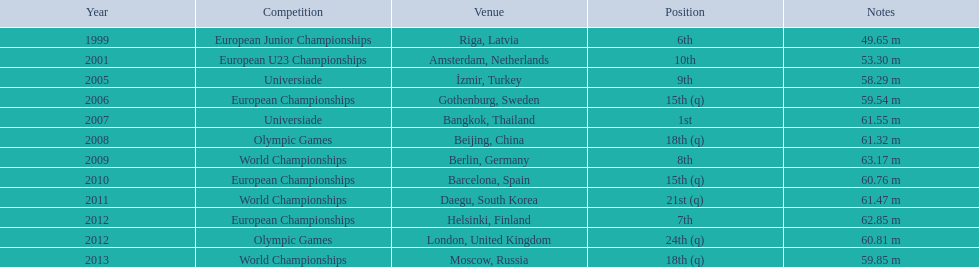Before competing in the 2012 olympics, what was his most recent contest? European Championships. Would you mind parsing the complete table? {'header': ['Year', 'Competition', 'Venue', 'Position', 'Notes'], 'rows': [['1999', 'European Junior Championships', 'Riga, Latvia', '6th', '49.65 m'], ['2001', 'European U23 Championships', 'Amsterdam, Netherlands', '10th', '53.30 m'], ['2005', 'Universiade', 'İzmir, Turkey', '9th', '58.29 m'], ['2006', 'European Championships', 'Gothenburg, Sweden', '15th (q)', '59.54 m'], ['2007', 'Universiade', 'Bangkok, Thailand', '1st', '61.55 m'], ['2008', 'Olympic Games', 'Beijing, China', '18th (q)', '61.32 m'], ['2009', 'World Championships', 'Berlin, Germany', '8th', '63.17 m'], ['2010', 'European Championships', 'Barcelona, Spain', '15th (q)', '60.76 m'], ['2011', 'World Championships', 'Daegu, South Korea', '21st (q)', '61.47 m'], ['2012', 'European Championships', 'Helsinki, Finland', '7th', '62.85 m'], ['2012', 'Olympic Games', 'London, United Kingdom', '24th (q)', '60.81 m'], ['2013', 'World Championships', 'Moscow, Russia', '18th (q)', '59.85 m']]} 